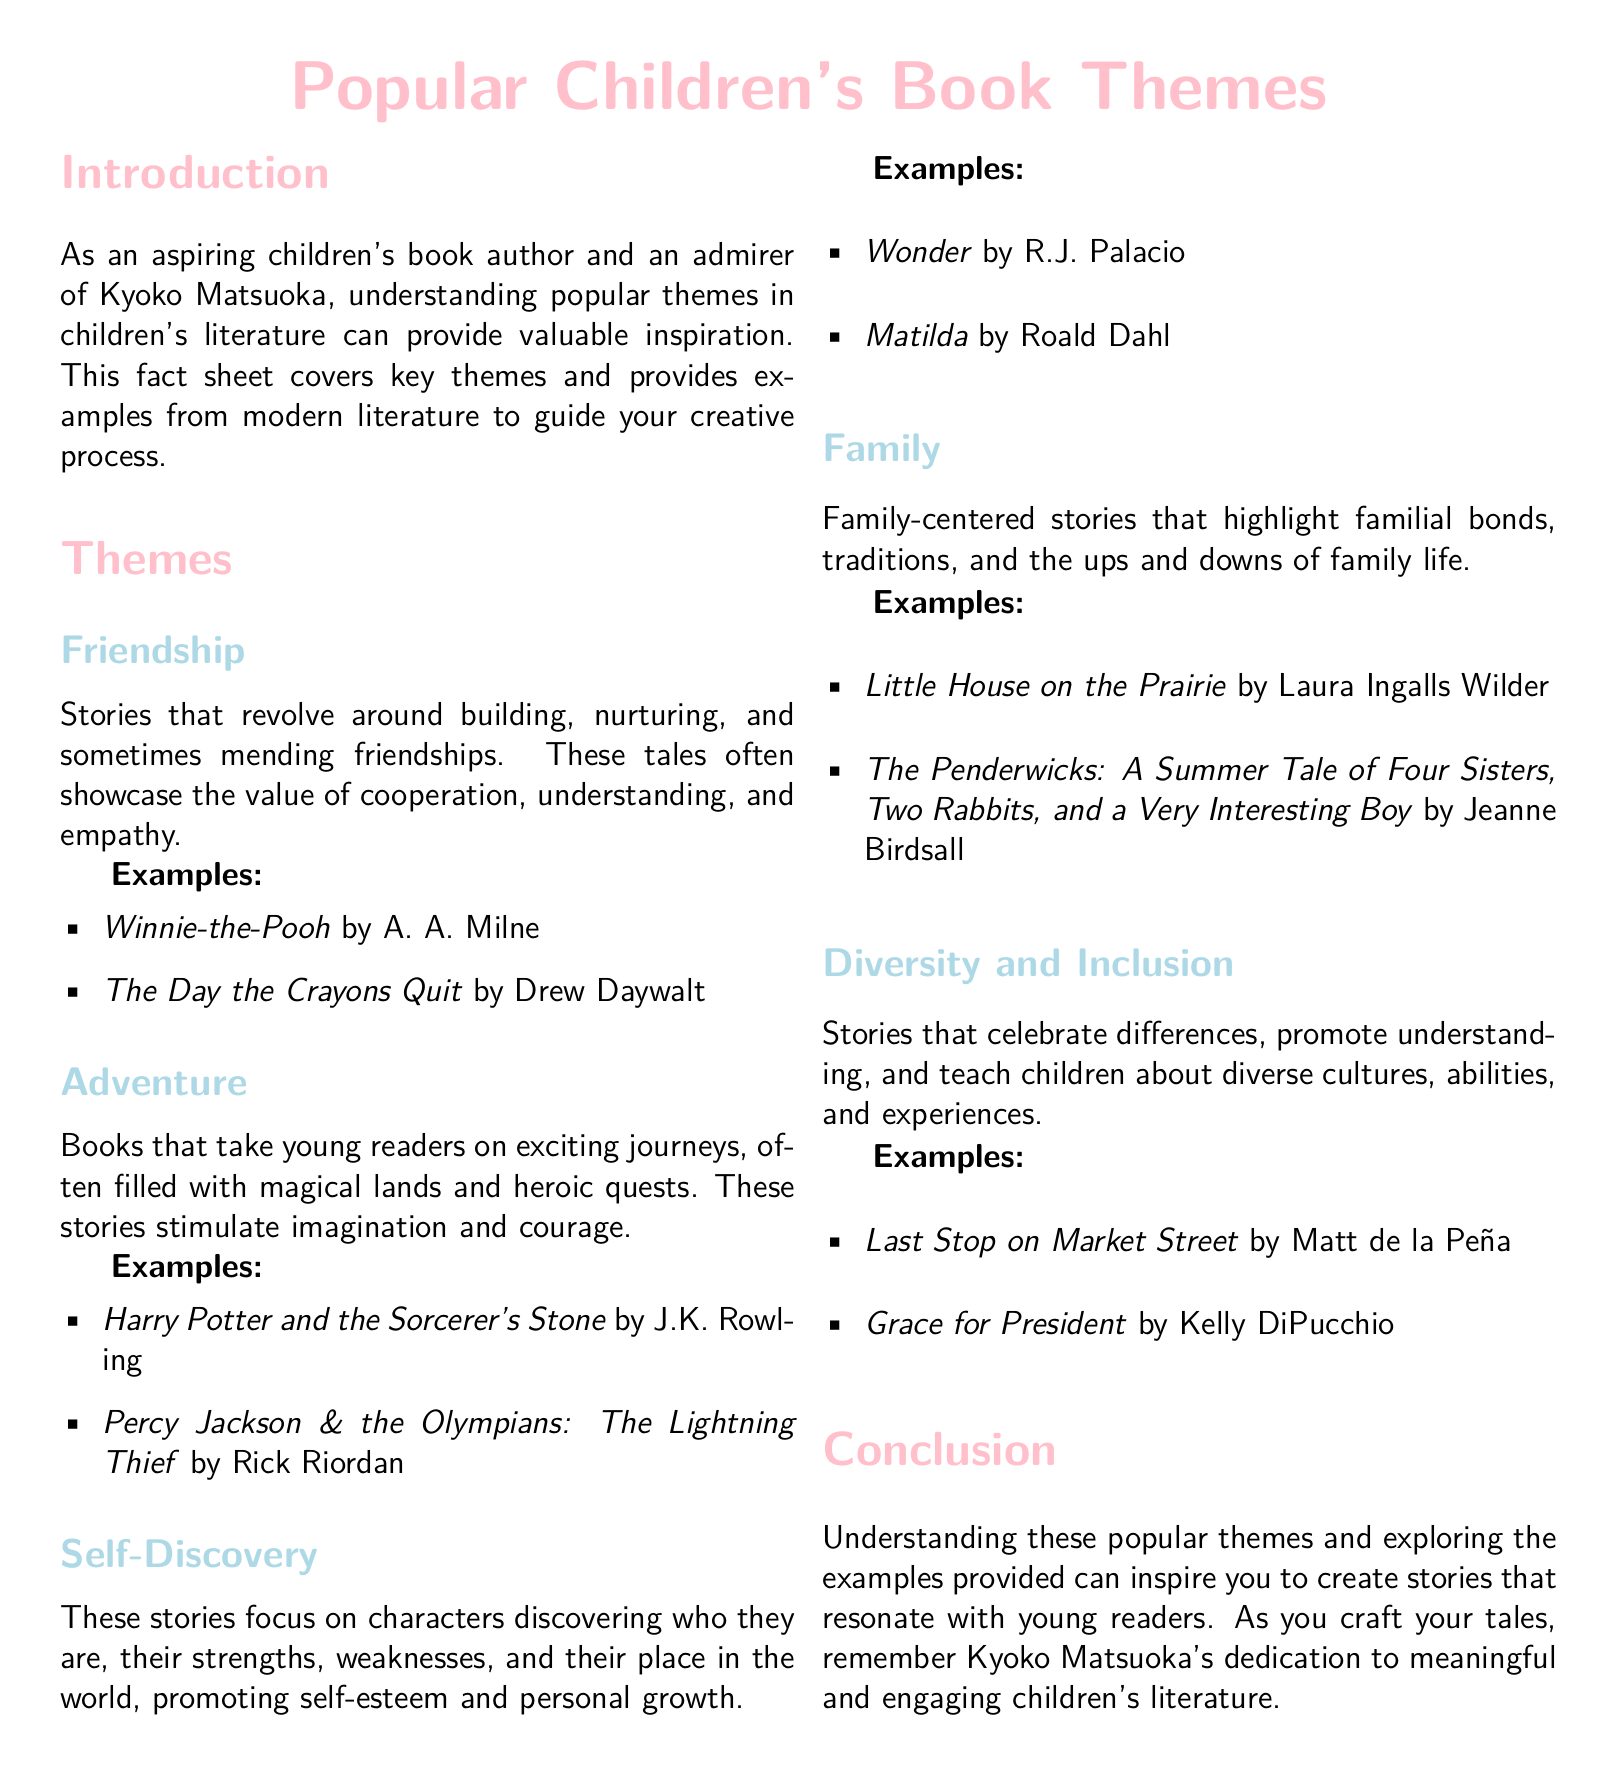what is the first theme listed in the document? The first theme in the list is "Friendship," which focuses on building and nurturing relationships.
Answer: Friendship name one example of an adventure-themed book. The document provides examples of adventure-themed books, and one of them is "Harry Potter and the Sorcerer's Stone."
Answer: Harry Potter and the Sorcerer's Stone how many themes are mentioned in total? The document lists five distinct themes in children's literature.
Answer: 5 which book is an example of a self-discovery theme? "Wonder" by R.J. Palacio is cited as an example of a self-discovery theme in the document.
Answer: Wonder what is the title of the last example listed under the diversity and inclusion theme? The last example provided under diversity and inclusion is "Grace for President."
Answer: Grace for President what is the central focus of family-centered stories mentioned in the document? Family-centered stories highlight familial bonds, traditions, and family life's ups and downs.
Answer: Familial bonds which author wrote "Little House on the Prairie"? The author of "Little House on the Prairie" is Laura Ingalls Wilder as mentioned in the document.
Answer: Laura Ingalls Wilder who is the intended audience for the themes discussed in the document? The document is oriented towards children's literature and targets young readers.
Answer: Young readers 